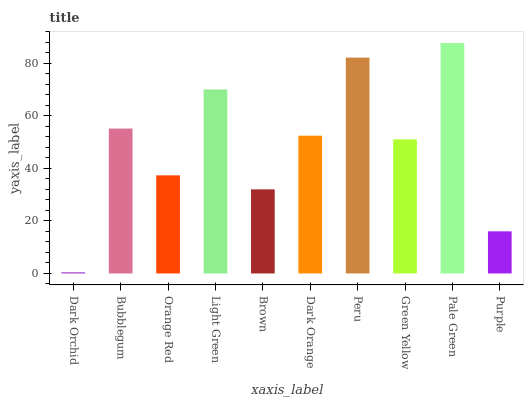Is Dark Orchid the minimum?
Answer yes or no. Yes. Is Pale Green the maximum?
Answer yes or no. Yes. Is Bubblegum the minimum?
Answer yes or no. No. Is Bubblegum the maximum?
Answer yes or no. No. Is Bubblegum greater than Dark Orchid?
Answer yes or no. Yes. Is Dark Orchid less than Bubblegum?
Answer yes or no. Yes. Is Dark Orchid greater than Bubblegum?
Answer yes or no. No. Is Bubblegum less than Dark Orchid?
Answer yes or no. No. Is Dark Orange the high median?
Answer yes or no. Yes. Is Green Yellow the low median?
Answer yes or no. Yes. Is Bubblegum the high median?
Answer yes or no. No. Is Bubblegum the low median?
Answer yes or no. No. 